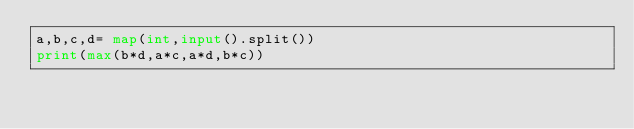<code> <loc_0><loc_0><loc_500><loc_500><_Python_>a,b,c,d= map(int,input().split())
print(max(b*d,a*c,a*d,b*c))
</code> 